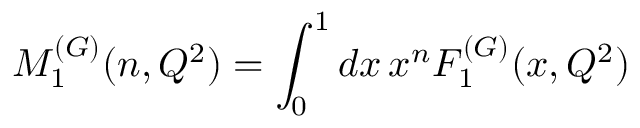Convert formula to latex. <formula><loc_0><loc_0><loc_500><loc_500>M _ { 1 } ^ { ( G ) } ( n , Q ^ { 2 } ) = \int _ { 0 } ^ { 1 } d x \, x ^ { n } F _ { 1 } ^ { ( G ) } ( x , Q ^ { 2 } )</formula> 